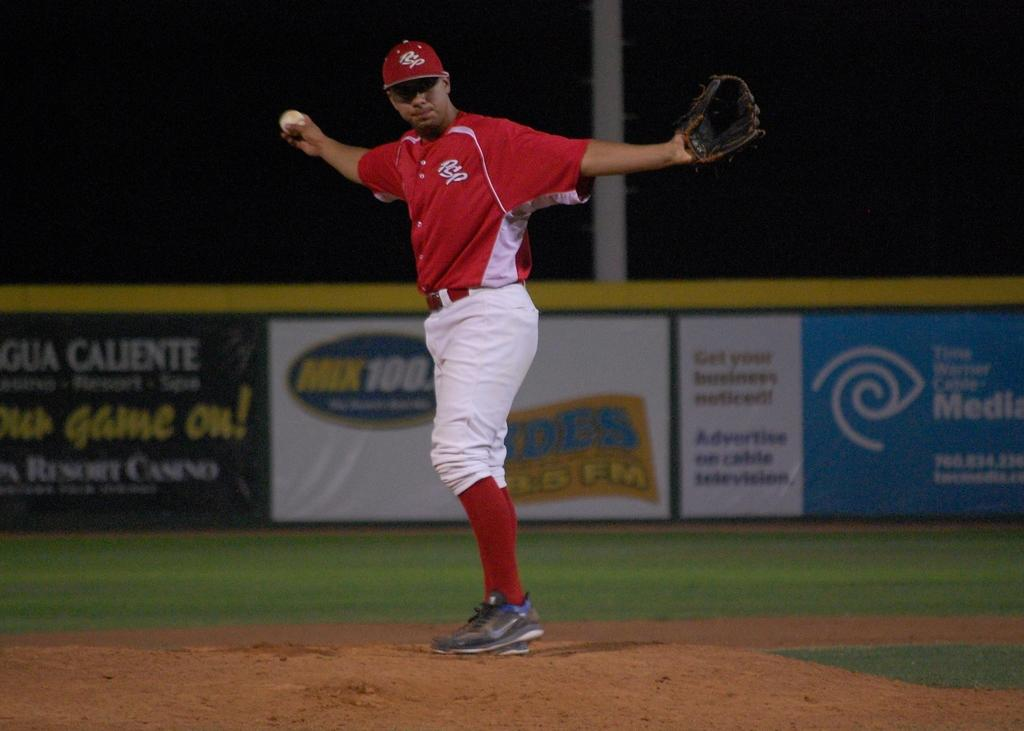<image>
Create a compact narrative representing the image presented. A baseball player wearing red and white stretched out his arms in front of advertising boards for various firms. 